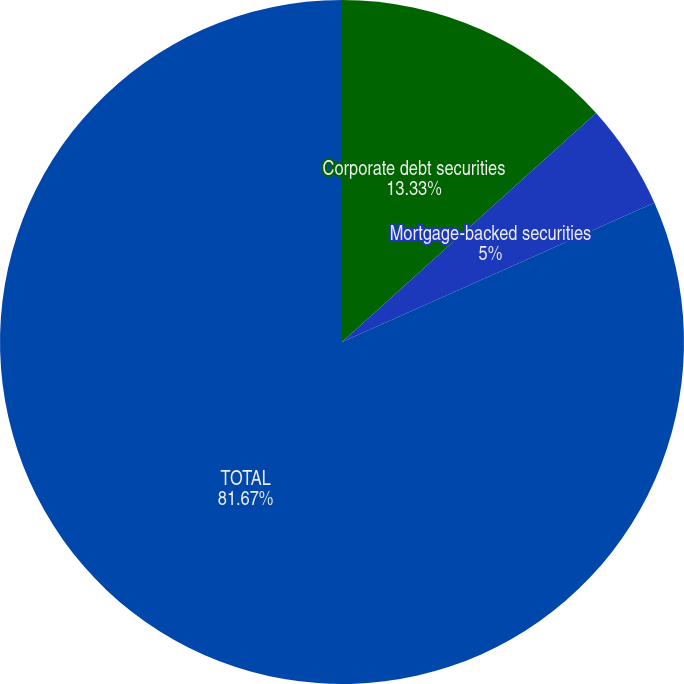<chart> <loc_0><loc_0><loc_500><loc_500><pie_chart><fcel>Corporate debt securities<fcel>Mortgage-backed securities<fcel>TOTAL<nl><fcel>13.33%<fcel>5.0%<fcel>81.67%<nl></chart> 